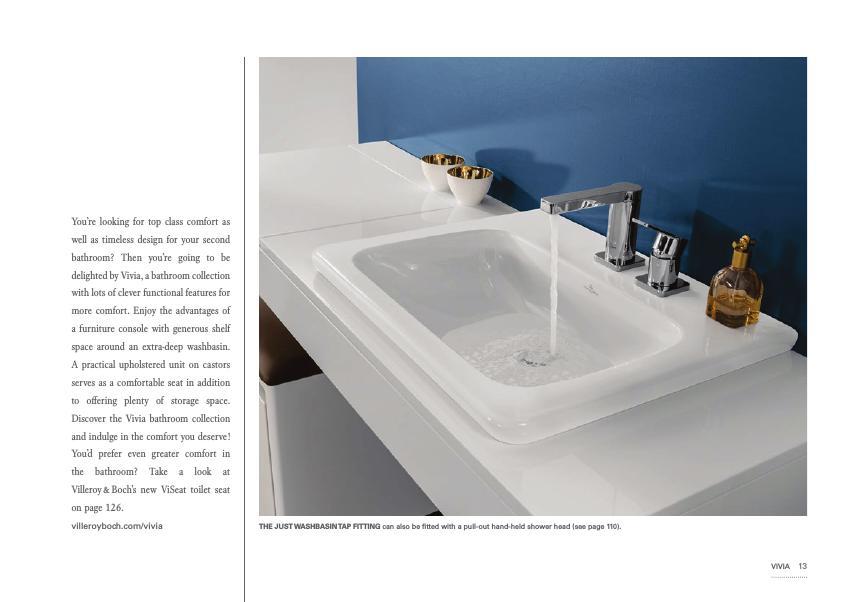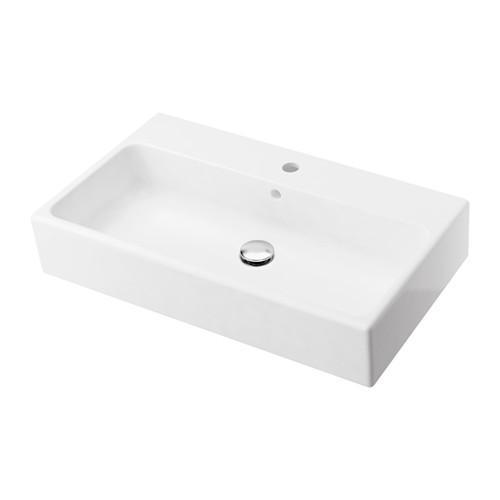The first image is the image on the left, the second image is the image on the right. Analyze the images presented: Is the assertion "The sink in the image on the left is set into a counter." valid? Answer yes or no. Yes. The first image is the image on the left, the second image is the image on the right. Evaluate the accuracy of this statement regarding the images: "One of the sinks is an oval shape inset into a white rectangle, with no faucet mounted.". Is it true? Answer yes or no. No. 